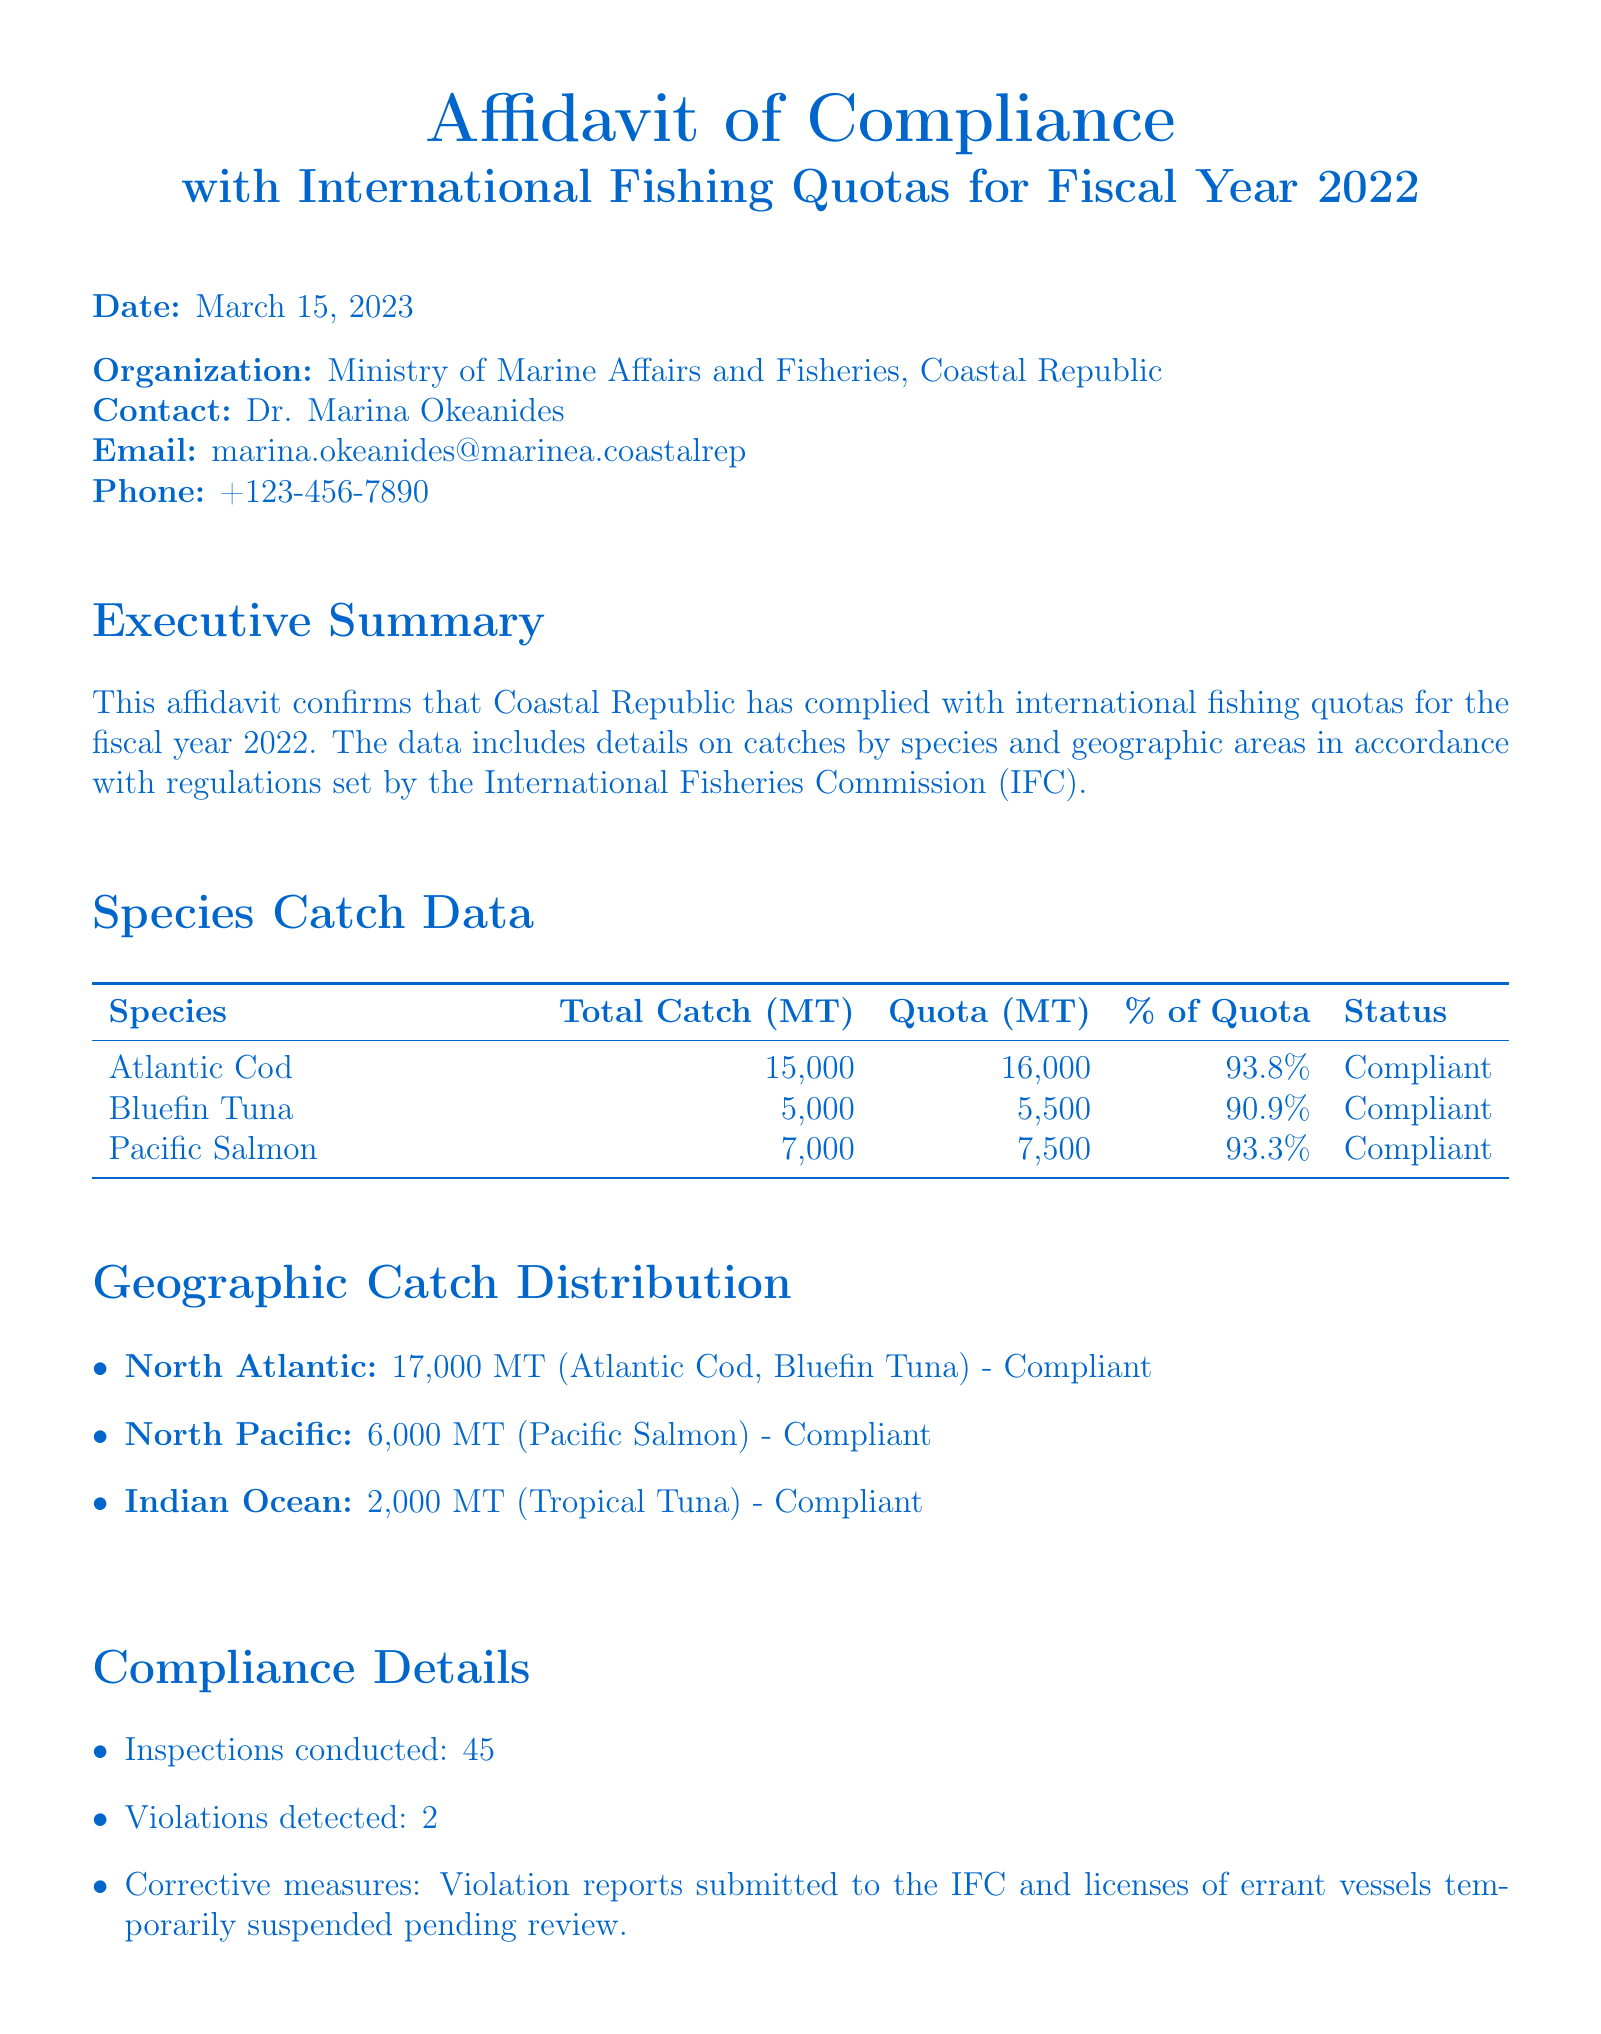What is the date of the affidavit? The date listed in the document is when the affidavit was issued, which is March 15, 2023.
Answer: March 15, 2023 Who is the contact person mentioned in the affidavit? The document identifies the contact person for the affidavit as Dr. Marina Okeanides.
Answer: Dr. Marina Okeanides What is the total catch of Atlantic Cod? The total catch for Atlantic Cod is specified in the catch data table within the document as 15,000 MT.
Answer: 15,000 MT What percentage of quota was utilized for Bluefin Tuna? The percentage of the quota used for Bluefin Tuna is represented in the table as 90.9%.
Answer: 90.9% How many inspections were conducted according to the compliance details? The document states that 45 inspections were carried out as per the compliance details section.
Answer: 45 What is the status of the species with the highest catch percentage? The highest catch percentage is 93.8% for Atlantic Cod, which is labeled as compliant in the document.
Answer: Compliant How many total catches (in MT) were reported in the North Atlantic? The document lists the total catches in the North Atlantic as 17,000 MT.
Answer: 17,000 MT What are the corrective measures mentioned in the compliance section? The compliance section states the corrective measures as violation reports submitted to the IFC and suspending licenses.
Answer: Violation reports submitted to the IFC and licenses suspended 